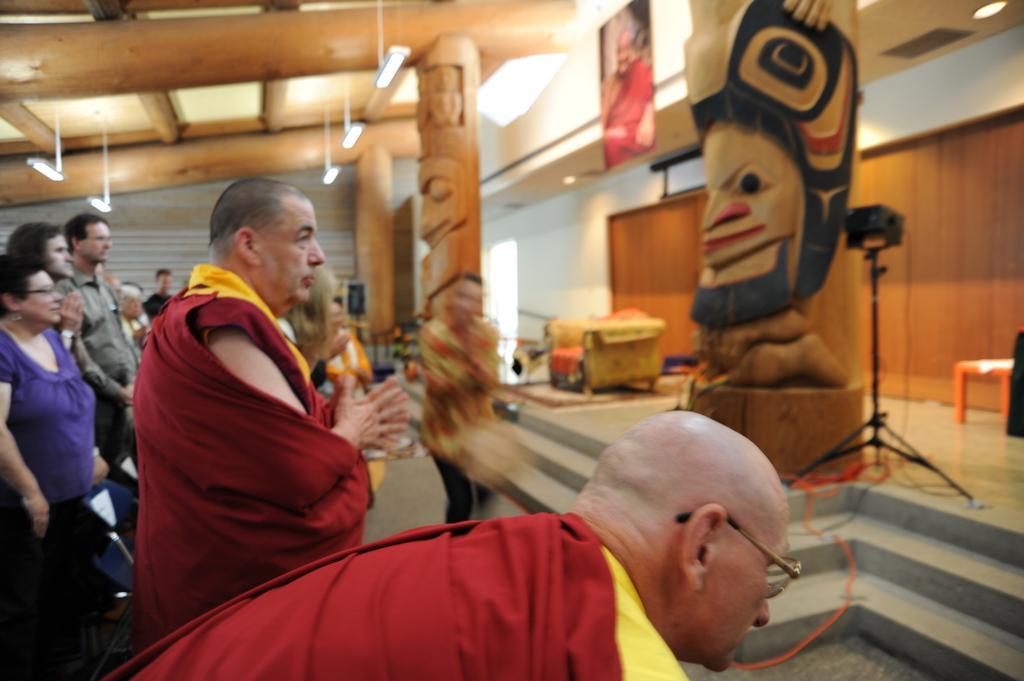How would you summarize this image in a sentence or two? In this image there are group of persons standing. On the right side there is stand which is black in colour and there is a statue and there is a frame on the wall hanging and there is an empty sofa. On the top there are lights hanging and there are pillars and steps and there are wires. 